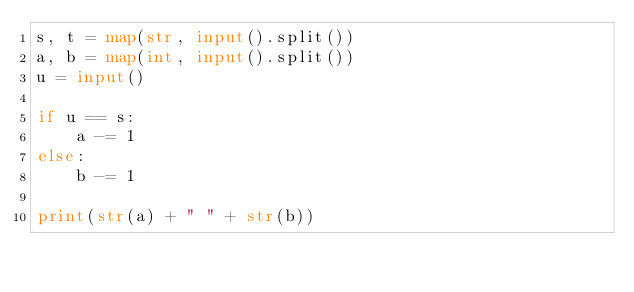Convert code to text. <code><loc_0><loc_0><loc_500><loc_500><_Python_>s, t = map(str, input().split())
a, b = map(int, input().split())
u = input()

if u == s:
    a -= 1
else:
    b -= 1

print(str(a) + " " + str(b))</code> 